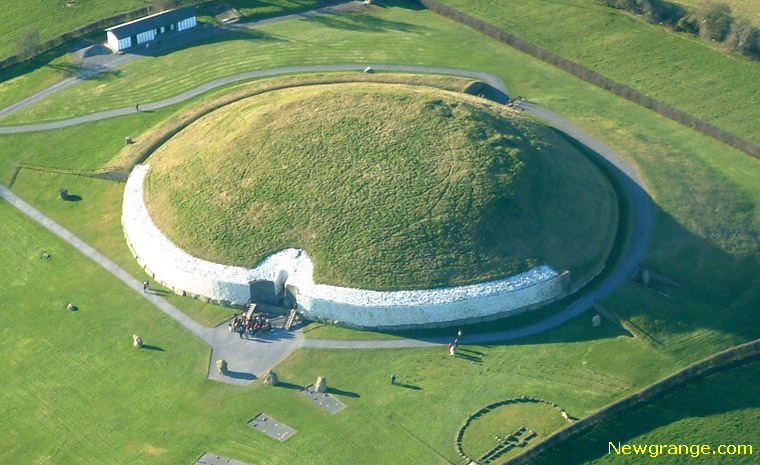If Newgrange were a character in a fantasy novel, what kind of character would it be? If Newgrange were a character in a fantasy novel, it would be portrayed as an ancient, wise guardian of time and knowledge. Cloaked in living green and imbued with a mystical aura, it stands as a sentinel watching over the land, a repository of forgotten lore and untold secrets. Its entrance, a portal veiled in mystery, leads to chambers where the past and future intertwine. This character, ancient and serene, would possess the ability to communicate with the stars, guiding heroes with wisdom gleaned from millennia of observing the celestial dance. It would be a character of benevolent power, a protector of history and a beacon of hope in times of darkness. 